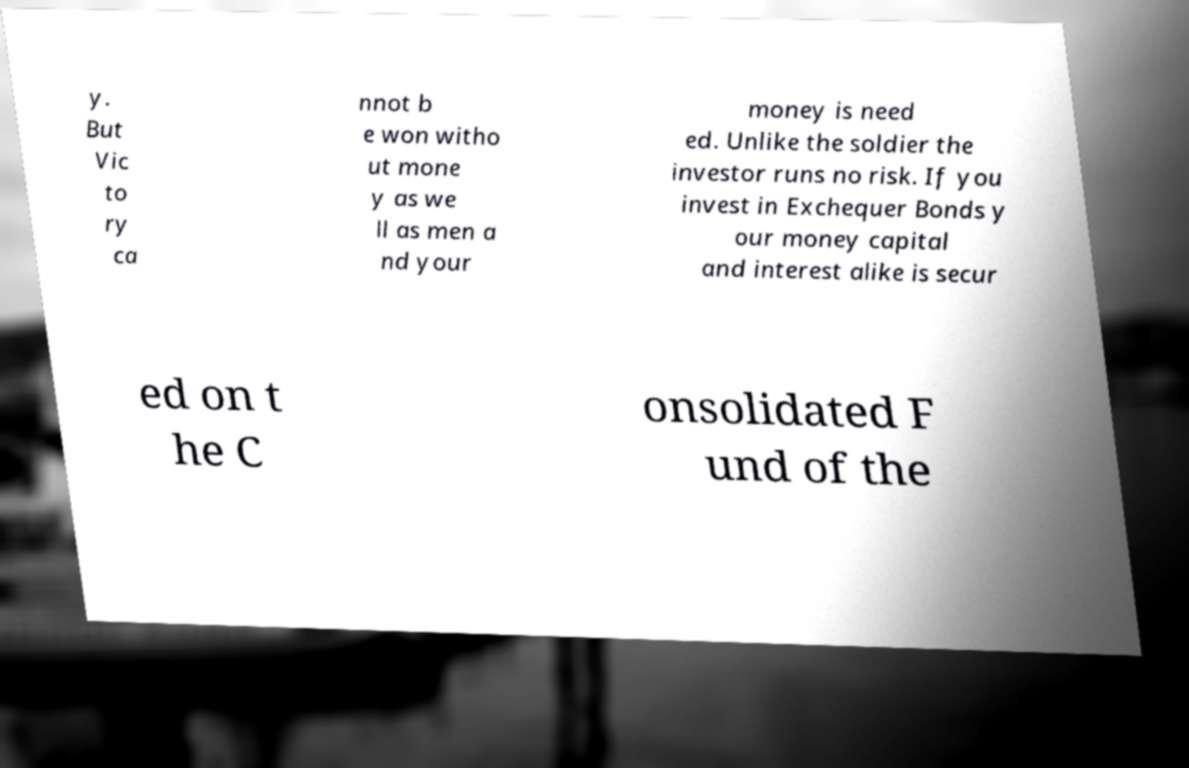Please identify and transcribe the text found in this image. y. But Vic to ry ca nnot b e won witho ut mone y as we ll as men a nd your money is need ed. Unlike the soldier the investor runs no risk. If you invest in Exchequer Bonds y our money capital and interest alike is secur ed on t he C onsolidated F und of the 